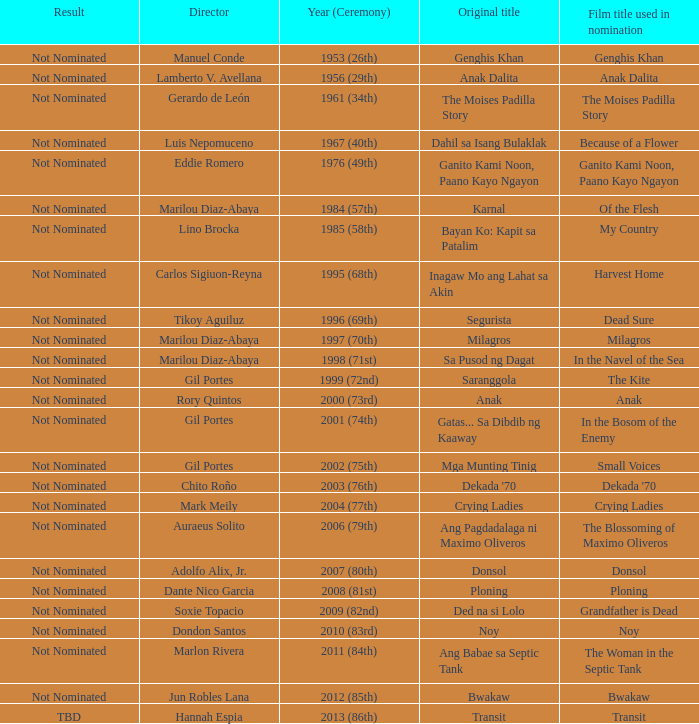Which director had not nominated as a result, and had Bayan Ko: Kapit Sa Patalim as an original title? Lino Brocka. 